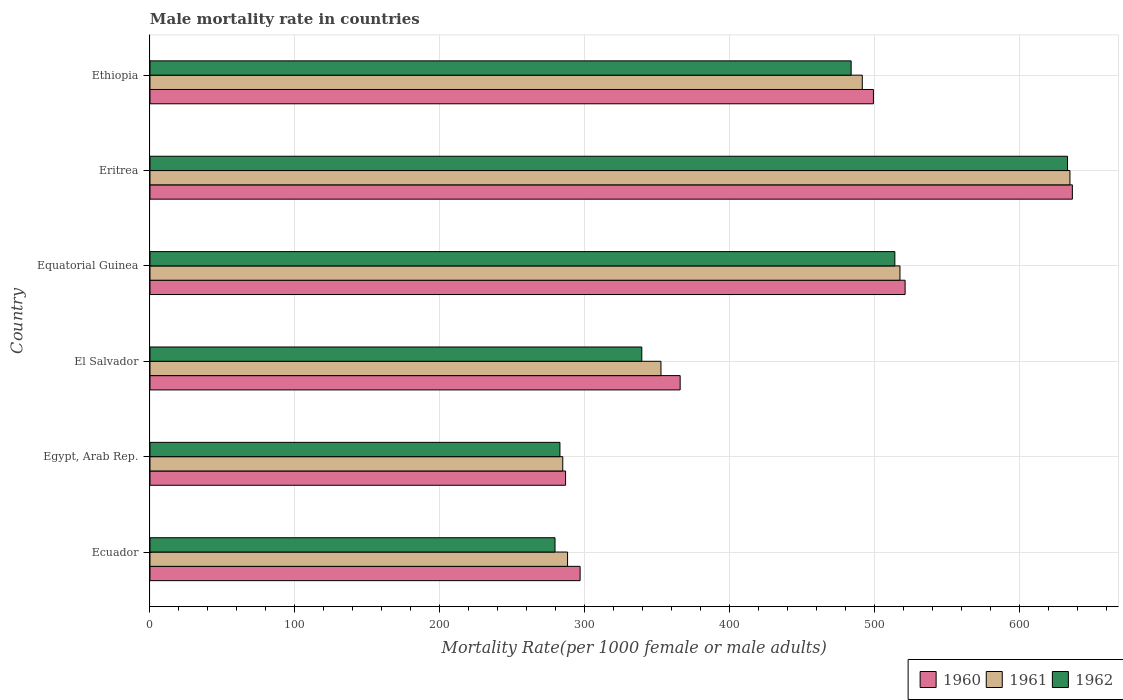How many groups of bars are there?
Give a very brief answer. 6. Are the number of bars per tick equal to the number of legend labels?
Your answer should be very brief. Yes. Are the number of bars on each tick of the Y-axis equal?
Ensure brevity in your answer.  Yes. What is the label of the 6th group of bars from the top?
Provide a short and direct response. Ecuador. In how many cases, is the number of bars for a given country not equal to the number of legend labels?
Ensure brevity in your answer.  0. What is the male mortality rate in 1961 in Equatorial Guinea?
Your answer should be compact. 517.37. Across all countries, what is the maximum male mortality rate in 1961?
Keep it short and to the point. 634.63. Across all countries, what is the minimum male mortality rate in 1962?
Your answer should be very brief. 279.4. In which country was the male mortality rate in 1961 maximum?
Your answer should be compact. Eritrea. In which country was the male mortality rate in 1960 minimum?
Keep it short and to the point. Egypt, Arab Rep. What is the total male mortality rate in 1962 in the graph?
Your answer should be compact. 2531.93. What is the difference between the male mortality rate in 1960 in Eritrea and that in Ethiopia?
Offer a very short reply. 137.24. What is the difference between the male mortality rate in 1960 in El Salvador and the male mortality rate in 1962 in Ecuador?
Provide a succinct answer. 86.32. What is the average male mortality rate in 1961 per country?
Provide a succinct answer. 428.11. What is the difference between the male mortality rate in 1960 and male mortality rate in 1961 in Equatorial Guinea?
Give a very brief answer. 3.54. In how many countries, is the male mortality rate in 1962 greater than 220 ?
Keep it short and to the point. 6. What is the ratio of the male mortality rate in 1962 in El Salvador to that in Ethiopia?
Offer a very short reply. 0.7. What is the difference between the highest and the second highest male mortality rate in 1960?
Your answer should be very brief. 115.39. What is the difference between the highest and the lowest male mortality rate in 1962?
Offer a terse response. 353.55. Is the sum of the male mortality rate in 1961 in Ecuador and El Salvador greater than the maximum male mortality rate in 1962 across all countries?
Give a very brief answer. Yes. What does the 1st bar from the top in Egypt, Arab Rep. represents?
Make the answer very short. 1962. What does the 2nd bar from the bottom in Ethiopia represents?
Offer a very short reply. 1961. Are all the bars in the graph horizontal?
Provide a succinct answer. Yes. Are the values on the major ticks of X-axis written in scientific E-notation?
Offer a very short reply. No. Where does the legend appear in the graph?
Your answer should be compact. Bottom right. How many legend labels are there?
Offer a very short reply. 3. How are the legend labels stacked?
Make the answer very short. Horizontal. What is the title of the graph?
Offer a very short reply. Male mortality rate in countries. What is the label or title of the X-axis?
Provide a succinct answer. Mortality Rate(per 1000 female or male adults). What is the Mortality Rate(per 1000 female or male adults) in 1960 in Ecuador?
Your response must be concise. 296.71. What is the Mortality Rate(per 1000 female or male adults) of 1961 in Ecuador?
Your response must be concise. 288.06. What is the Mortality Rate(per 1000 female or male adults) of 1962 in Ecuador?
Your answer should be very brief. 279.4. What is the Mortality Rate(per 1000 female or male adults) of 1960 in Egypt, Arab Rep.?
Make the answer very short. 286.69. What is the Mortality Rate(per 1000 female or male adults) of 1961 in Egypt, Arab Rep.?
Give a very brief answer. 284.74. What is the Mortality Rate(per 1000 female or male adults) in 1962 in Egypt, Arab Rep.?
Your response must be concise. 282.8. What is the Mortality Rate(per 1000 female or male adults) of 1960 in El Salvador?
Provide a short and direct response. 365.73. What is the Mortality Rate(per 1000 female or male adults) of 1961 in El Salvador?
Provide a short and direct response. 352.5. What is the Mortality Rate(per 1000 female or male adults) in 1962 in El Salvador?
Your answer should be very brief. 339.27. What is the Mortality Rate(per 1000 female or male adults) in 1960 in Equatorial Guinea?
Provide a succinct answer. 520.91. What is the Mortality Rate(per 1000 female or male adults) of 1961 in Equatorial Guinea?
Give a very brief answer. 517.37. What is the Mortality Rate(per 1000 female or male adults) in 1962 in Equatorial Guinea?
Give a very brief answer. 513.83. What is the Mortality Rate(per 1000 female or male adults) in 1960 in Eritrea?
Your answer should be very brief. 636.3. What is the Mortality Rate(per 1000 female or male adults) in 1961 in Eritrea?
Provide a succinct answer. 634.63. What is the Mortality Rate(per 1000 female or male adults) of 1962 in Eritrea?
Give a very brief answer. 632.96. What is the Mortality Rate(per 1000 female or male adults) in 1960 in Ethiopia?
Offer a terse response. 499.05. What is the Mortality Rate(per 1000 female or male adults) in 1961 in Ethiopia?
Provide a succinct answer. 491.37. What is the Mortality Rate(per 1000 female or male adults) in 1962 in Ethiopia?
Keep it short and to the point. 483.68. Across all countries, what is the maximum Mortality Rate(per 1000 female or male adults) in 1960?
Ensure brevity in your answer.  636.3. Across all countries, what is the maximum Mortality Rate(per 1000 female or male adults) in 1961?
Offer a terse response. 634.63. Across all countries, what is the maximum Mortality Rate(per 1000 female or male adults) of 1962?
Provide a succinct answer. 632.96. Across all countries, what is the minimum Mortality Rate(per 1000 female or male adults) of 1960?
Provide a short and direct response. 286.69. Across all countries, what is the minimum Mortality Rate(per 1000 female or male adults) of 1961?
Make the answer very short. 284.74. Across all countries, what is the minimum Mortality Rate(per 1000 female or male adults) of 1962?
Offer a terse response. 279.4. What is the total Mortality Rate(per 1000 female or male adults) of 1960 in the graph?
Provide a short and direct response. 2605.39. What is the total Mortality Rate(per 1000 female or male adults) in 1961 in the graph?
Give a very brief answer. 2568.66. What is the total Mortality Rate(per 1000 female or male adults) of 1962 in the graph?
Offer a terse response. 2531.93. What is the difference between the Mortality Rate(per 1000 female or male adults) of 1960 in Ecuador and that in Egypt, Arab Rep.?
Your response must be concise. 10.02. What is the difference between the Mortality Rate(per 1000 female or male adults) in 1961 in Ecuador and that in Egypt, Arab Rep.?
Ensure brevity in your answer.  3.32. What is the difference between the Mortality Rate(per 1000 female or male adults) of 1962 in Ecuador and that in Egypt, Arab Rep.?
Provide a succinct answer. -3.39. What is the difference between the Mortality Rate(per 1000 female or male adults) of 1960 in Ecuador and that in El Salvador?
Provide a short and direct response. -69.01. What is the difference between the Mortality Rate(per 1000 female or male adults) in 1961 in Ecuador and that in El Salvador?
Offer a very short reply. -64.44. What is the difference between the Mortality Rate(per 1000 female or male adults) in 1962 in Ecuador and that in El Salvador?
Your answer should be very brief. -59.86. What is the difference between the Mortality Rate(per 1000 female or male adults) in 1960 in Ecuador and that in Equatorial Guinea?
Offer a very short reply. -224.2. What is the difference between the Mortality Rate(per 1000 female or male adults) in 1961 in Ecuador and that in Equatorial Guinea?
Ensure brevity in your answer.  -229.31. What is the difference between the Mortality Rate(per 1000 female or male adults) of 1962 in Ecuador and that in Equatorial Guinea?
Provide a succinct answer. -234.42. What is the difference between the Mortality Rate(per 1000 female or male adults) of 1960 in Ecuador and that in Eritrea?
Offer a very short reply. -339.58. What is the difference between the Mortality Rate(per 1000 female or male adults) of 1961 in Ecuador and that in Eritrea?
Keep it short and to the point. -346.57. What is the difference between the Mortality Rate(per 1000 female or male adults) in 1962 in Ecuador and that in Eritrea?
Provide a short and direct response. -353.55. What is the difference between the Mortality Rate(per 1000 female or male adults) of 1960 in Ecuador and that in Ethiopia?
Your answer should be compact. -202.34. What is the difference between the Mortality Rate(per 1000 female or male adults) in 1961 in Ecuador and that in Ethiopia?
Your response must be concise. -203.31. What is the difference between the Mortality Rate(per 1000 female or male adults) of 1962 in Ecuador and that in Ethiopia?
Offer a terse response. -204.28. What is the difference between the Mortality Rate(per 1000 female or male adults) of 1960 in Egypt, Arab Rep. and that in El Salvador?
Make the answer very short. -79.03. What is the difference between the Mortality Rate(per 1000 female or male adults) of 1961 in Egypt, Arab Rep. and that in El Salvador?
Ensure brevity in your answer.  -67.75. What is the difference between the Mortality Rate(per 1000 female or male adults) in 1962 in Egypt, Arab Rep. and that in El Salvador?
Keep it short and to the point. -56.47. What is the difference between the Mortality Rate(per 1000 female or male adults) in 1960 in Egypt, Arab Rep. and that in Equatorial Guinea?
Your response must be concise. -234.22. What is the difference between the Mortality Rate(per 1000 female or male adults) of 1961 in Egypt, Arab Rep. and that in Equatorial Guinea?
Your response must be concise. -232.62. What is the difference between the Mortality Rate(per 1000 female or male adults) in 1962 in Egypt, Arab Rep. and that in Equatorial Guinea?
Your answer should be very brief. -231.03. What is the difference between the Mortality Rate(per 1000 female or male adults) in 1960 in Egypt, Arab Rep. and that in Eritrea?
Your answer should be compact. -349.61. What is the difference between the Mortality Rate(per 1000 female or male adults) in 1961 in Egypt, Arab Rep. and that in Eritrea?
Your answer should be very brief. -349.88. What is the difference between the Mortality Rate(per 1000 female or male adults) in 1962 in Egypt, Arab Rep. and that in Eritrea?
Provide a succinct answer. -350.16. What is the difference between the Mortality Rate(per 1000 female or male adults) of 1960 in Egypt, Arab Rep. and that in Ethiopia?
Your response must be concise. -212.36. What is the difference between the Mortality Rate(per 1000 female or male adults) of 1961 in Egypt, Arab Rep. and that in Ethiopia?
Offer a very short reply. -206.62. What is the difference between the Mortality Rate(per 1000 female or male adults) of 1962 in Egypt, Arab Rep. and that in Ethiopia?
Make the answer very short. -200.89. What is the difference between the Mortality Rate(per 1000 female or male adults) in 1960 in El Salvador and that in Equatorial Guinea?
Keep it short and to the point. -155.19. What is the difference between the Mortality Rate(per 1000 female or male adults) in 1961 in El Salvador and that in Equatorial Guinea?
Your response must be concise. -164.87. What is the difference between the Mortality Rate(per 1000 female or male adults) in 1962 in El Salvador and that in Equatorial Guinea?
Provide a short and direct response. -174.56. What is the difference between the Mortality Rate(per 1000 female or male adults) of 1960 in El Salvador and that in Eritrea?
Your answer should be compact. -270.57. What is the difference between the Mortality Rate(per 1000 female or male adults) in 1961 in El Salvador and that in Eritrea?
Your answer should be very brief. -282.13. What is the difference between the Mortality Rate(per 1000 female or male adults) in 1962 in El Salvador and that in Eritrea?
Keep it short and to the point. -293.69. What is the difference between the Mortality Rate(per 1000 female or male adults) of 1960 in El Salvador and that in Ethiopia?
Your response must be concise. -133.33. What is the difference between the Mortality Rate(per 1000 female or male adults) of 1961 in El Salvador and that in Ethiopia?
Give a very brief answer. -138.87. What is the difference between the Mortality Rate(per 1000 female or male adults) of 1962 in El Salvador and that in Ethiopia?
Provide a short and direct response. -144.42. What is the difference between the Mortality Rate(per 1000 female or male adults) in 1960 in Equatorial Guinea and that in Eritrea?
Ensure brevity in your answer.  -115.39. What is the difference between the Mortality Rate(per 1000 female or male adults) of 1961 in Equatorial Guinea and that in Eritrea?
Ensure brevity in your answer.  -117.26. What is the difference between the Mortality Rate(per 1000 female or male adults) in 1962 in Equatorial Guinea and that in Eritrea?
Make the answer very short. -119.13. What is the difference between the Mortality Rate(per 1000 female or male adults) of 1960 in Equatorial Guinea and that in Ethiopia?
Your answer should be very brief. 21.86. What is the difference between the Mortality Rate(per 1000 female or male adults) of 1961 in Equatorial Guinea and that in Ethiopia?
Offer a very short reply. 26. What is the difference between the Mortality Rate(per 1000 female or male adults) in 1962 in Equatorial Guinea and that in Ethiopia?
Provide a short and direct response. 30.15. What is the difference between the Mortality Rate(per 1000 female or male adults) of 1960 in Eritrea and that in Ethiopia?
Ensure brevity in your answer.  137.24. What is the difference between the Mortality Rate(per 1000 female or male adults) in 1961 in Eritrea and that in Ethiopia?
Your answer should be very brief. 143.26. What is the difference between the Mortality Rate(per 1000 female or male adults) in 1962 in Eritrea and that in Ethiopia?
Ensure brevity in your answer.  149.28. What is the difference between the Mortality Rate(per 1000 female or male adults) in 1960 in Ecuador and the Mortality Rate(per 1000 female or male adults) in 1961 in Egypt, Arab Rep.?
Offer a terse response. 11.97. What is the difference between the Mortality Rate(per 1000 female or male adults) of 1960 in Ecuador and the Mortality Rate(per 1000 female or male adults) of 1962 in Egypt, Arab Rep.?
Your answer should be compact. 13.92. What is the difference between the Mortality Rate(per 1000 female or male adults) of 1961 in Ecuador and the Mortality Rate(per 1000 female or male adults) of 1962 in Egypt, Arab Rep.?
Give a very brief answer. 5.26. What is the difference between the Mortality Rate(per 1000 female or male adults) in 1960 in Ecuador and the Mortality Rate(per 1000 female or male adults) in 1961 in El Salvador?
Make the answer very short. -55.78. What is the difference between the Mortality Rate(per 1000 female or male adults) of 1960 in Ecuador and the Mortality Rate(per 1000 female or male adults) of 1962 in El Salvador?
Keep it short and to the point. -42.55. What is the difference between the Mortality Rate(per 1000 female or male adults) of 1961 in Ecuador and the Mortality Rate(per 1000 female or male adults) of 1962 in El Salvador?
Your answer should be very brief. -51.21. What is the difference between the Mortality Rate(per 1000 female or male adults) of 1960 in Ecuador and the Mortality Rate(per 1000 female or male adults) of 1961 in Equatorial Guinea?
Make the answer very short. -220.66. What is the difference between the Mortality Rate(per 1000 female or male adults) of 1960 in Ecuador and the Mortality Rate(per 1000 female or male adults) of 1962 in Equatorial Guinea?
Ensure brevity in your answer.  -217.11. What is the difference between the Mortality Rate(per 1000 female or male adults) in 1961 in Ecuador and the Mortality Rate(per 1000 female or male adults) in 1962 in Equatorial Guinea?
Offer a terse response. -225.77. What is the difference between the Mortality Rate(per 1000 female or male adults) of 1960 in Ecuador and the Mortality Rate(per 1000 female or male adults) of 1961 in Eritrea?
Your answer should be compact. -337.91. What is the difference between the Mortality Rate(per 1000 female or male adults) of 1960 in Ecuador and the Mortality Rate(per 1000 female or male adults) of 1962 in Eritrea?
Your response must be concise. -336.24. What is the difference between the Mortality Rate(per 1000 female or male adults) in 1961 in Ecuador and the Mortality Rate(per 1000 female or male adults) in 1962 in Eritrea?
Ensure brevity in your answer.  -344.9. What is the difference between the Mortality Rate(per 1000 female or male adults) of 1960 in Ecuador and the Mortality Rate(per 1000 female or male adults) of 1961 in Ethiopia?
Your answer should be compact. -194.65. What is the difference between the Mortality Rate(per 1000 female or male adults) in 1960 in Ecuador and the Mortality Rate(per 1000 female or male adults) in 1962 in Ethiopia?
Provide a succinct answer. -186.97. What is the difference between the Mortality Rate(per 1000 female or male adults) in 1961 in Ecuador and the Mortality Rate(per 1000 female or male adults) in 1962 in Ethiopia?
Your response must be concise. -195.62. What is the difference between the Mortality Rate(per 1000 female or male adults) of 1960 in Egypt, Arab Rep. and the Mortality Rate(per 1000 female or male adults) of 1961 in El Salvador?
Provide a succinct answer. -65.8. What is the difference between the Mortality Rate(per 1000 female or male adults) in 1960 in Egypt, Arab Rep. and the Mortality Rate(per 1000 female or male adults) in 1962 in El Salvador?
Provide a succinct answer. -52.57. What is the difference between the Mortality Rate(per 1000 female or male adults) of 1961 in Egypt, Arab Rep. and the Mortality Rate(per 1000 female or male adults) of 1962 in El Salvador?
Offer a terse response. -54.52. What is the difference between the Mortality Rate(per 1000 female or male adults) of 1960 in Egypt, Arab Rep. and the Mortality Rate(per 1000 female or male adults) of 1961 in Equatorial Guinea?
Make the answer very short. -230.68. What is the difference between the Mortality Rate(per 1000 female or male adults) in 1960 in Egypt, Arab Rep. and the Mortality Rate(per 1000 female or male adults) in 1962 in Equatorial Guinea?
Your response must be concise. -227.14. What is the difference between the Mortality Rate(per 1000 female or male adults) in 1961 in Egypt, Arab Rep. and the Mortality Rate(per 1000 female or male adults) in 1962 in Equatorial Guinea?
Your answer should be compact. -229.08. What is the difference between the Mortality Rate(per 1000 female or male adults) in 1960 in Egypt, Arab Rep. and the Mortality Rate(per 1000 female or male adults) in 1961 in Eritrea?
Your answer should be very brief. -347.94. What is the difference between the Mortality Rate(per 1000 female or male adults) in 1960 in Egypt, Arab Rep. and the Mortality Rate(per 1000 female or male adults) in 1962 in Eritrea?
Keep it short and to the point. -346.26. What is the difference between the Mortality Rate(per 1000 female or male adults) in 1961 in Egypt, Arab Rep. and the Mortality Rate(per 1000 female or male adults) in 1962 in Eritrea?
Your response must be concise. -348.21. What is the difference between the Mortality Rate(per 1000 female or male adults) in 1960 in Egypt, Arab Rep. and the Mortality Rate(per 1000 female or male adults) in 1961 in Ethiopia?
Your answer should be very brief. -204.68. What is the difference between the Mortality Rate(per 1000 female or male adults) of 1960 in Egypt, Arab Rep. and the Mortality Rate(per 1000 female or male adults) of 1962 in Ethiopia?
Give a very brief answer. -196.99. What is the difference between the Mortality Rate(per 1000 female or male adults) of 1961 in Egypt, Arab Rep. and the Mortality Rate(per 1000 female or male adults) of 1962 in Ethiopia?
Offer a very short reply. -198.94. What is the difference between the Mortality Rate(per 1000 female or male adults) in 1960 in El Salvador and the Mortality Rate(per 1000 female or male adults) in 1961 in Equatorial Guinea?
Your response must be concise. -151.64. What is the difference between the Mortality Rate(per 1000 female or male adults) of 1960 in El Salvador and the Mortality Rate(per 1000 female or male adults) of 1962 in Equatorial Guinea?
Ensure brevity in your answer.  -148.1. What is the difference between the Mortality Rate(per 1000 female or male adults) of 1961 in El Salvador and the Mortality Rate(per 1000 female or male adults) of 1962 in Equatorial Guinea?
Make the answer very short. -161.33. What is the difference between the Mortality Rate(per 1000 female or male adults) in 1960 in El Salvador and the Mortality Rate(per 1000 female or male adults) in 1961 in Eritrea?
Give a very brief answer. -268.9. What is the difference between the Mortality Rate(per 1000 female or male adults) in 1960 in El Salvador and the Mortality Rate(per 1000 female or male adults) in 1962 in Eritrea?
Make the answer very short. -267.23. What is the difference between the Mortality Rate(per 1000 female or male adults) in 1961 in El Salvador and the Mortality Rate(per 1000 female or male adults) in 1962 in Eritrea?
Provide a succinct answer. -280.46. What is the difference between the Mortality Rate(per 1000 female or male adults) in 1960 in El Salvador and the Mortality Rate(per 1000 female or male adults) in 1961 in Ethiopia?
Offer a terse response. -125.64. What is the difference between the Mortality Rate(per 1000 female or male adults) of 1960 in El Salvador and the Mortality Rate(per 1000 female or male adults) of 1962 in Ethiopia?
Your response must be concise. -117.96. What is the difference between the Mortality Rate(per 1000 female or male adults) of 1961 in El Salvador and the Mortality Rate(per 1000 female or male adults) of 1962 in Ethiopia?
Your answer should be very brief. -131.19. What is the difference between the Mortality Rate(per 1000 female or male adults) of 1960 in Equatorial Guinea and the Mortality Rate(per 1000 female or male adults) of 1961 in Eritrea?
Keep it short and to the point. -113.72. What is the difference between the Mortality Rate(per 1000 female or male adults) in 1960 in Equatorial Guinea and the Mortality Rate(per 1000 female or male adults) in 1962 in Eritrea?
Offer a terse response. -112.05. What is the difference between the Mortality Rate(per 1000 female or male adults) in 1961 in Equatorial Guinea and the Mortality Rate(per 1000 female or male adults) in 1962 in Eritrea?
Your answer should be compact. -115.59. What is the difference between the Mortality Rate(per 1000 female or male adults) in 1960 in Equatorial Guinea and the Mortality Rate(per 1000 female or male adults) in 1961 in Ethiopia?
Offer a terse response. 29.54. What is the difference between the Mortality Rate(per 1000 female or male adults) in 1960 in Equatorial Guinea and the Mortality Rate(per 1000 female or male adults) in 1962 in Ethiopia?
Ensure brevity in your answer.  37.23. What is the difference between the Mortality Rate(per 1000 female or male adults) in 1961 in Equatorial Guinea and the Mortality Rate(per 1000 female or male adults) in 1962 in Ethiopia?
Provide a short and direct response. 33.69. What is the difference between the Mortality Rate(per 1000 female or male adults) of 1960 in Eritrea and the Mortality Rate(per 1000 female or male adults) of 1961 in Ethiopia?
Ensure brevity in your answer.  144.93. What is the difference between the Mortality Rate(per 1000 female or male adults) of 1960 in Eritrea and the Mortality Rate(per 1000 female or male adults) of 1962 in Ethiopia?
Provide a succinct answer. 152.62. What is the difference between the Mortality Rate(per 1000 female or male adults) in 1961 in Eritrea and the Mortality Rate(per 1000 female or male adults) in 1962 in Ethiopia?
Your response must be concise. 150.94. What is the average Mortality Rate(per 1000 female or male adults) of 1960 per country?
Offer a terse response. 434.23. What is the average Mortality Rate(per 1000 female or male adults) of 1961 per country?
Provide a succinct answer. 428.11. What is the average Mortality Rate(per 1000 female or male adults) of 1962 per country?
Keep it short and to the point. 421.99. What is the difference between the Mortality Rate(per 1000 female or male adults) in 1960 and Mortality Rate(per 1000 female or male adults) in 1961 in Ecuador?
Your response must be concise. 8.65. What is the difference between the Mortality Rate(per 1000 female or male adults) of 1960 and Mortality Rate(per 1000 female or male adults) of 1962 in Ecuador?
Your response must be concise. 17.31. What is the difference between the Mortality Rate(per 1000 female or male adults) in 1961 and Mortality Rate(per 1000 female or male adults) in 1962 in Ecuador?
Offer a very short reply. 8.65. What is the difference between the Mortality Rate(per 1000 female or male adults) in 1960 and Mortality Rate(per 1000 female or male adults) in 1961 in Egypt, Arab Rep.?
Offer a terse response. 1.95. What is the difference between the Mortality Rate(per 1000 female or male adults) of 1960 and Mortality Rate(per 1000 female or male adults) of 1962 in Egypt, Arab Rep.?
Your answer should be compact. 3.9. What is the difference between the Mortality Rate(per 1000 female or male adults) in 1961 and Mortality Rate(per 1000 female or male adults) in 1962 in Egypt, Arab Rep.?
Your response must be concise. 1.95. What is the difference between the Mortality Rate(per 1000 female or male adults) in 1960 and Mortality Rate(per 1000 female or male adults) in 1961 in El Salvador?
Provide a short and direct response. 13.23. What is the difference between the Mortality Rate(per 1000 female or male adults) of 1960 and Mortality Rate(per 1000 female or male adults) of 1962 in El Salvador?
Provide a succinct answer. 26.46. What is the difference between the Mortality Rate(per 1000 female or male adults) of 1961 and Mortality Rate(per 1000 female or male adults) of 1962 in El Salvador?
Give a very brief answer. 13.23. What is the difference between the Mortality Rate(per 1000 female or male adults) in 1960 and Mortality Rate(per 1000 female or male adults) in 1961 in Equatorial Guinea?
Provide a succinct answer. 3.54. What is the difference between the Mortality Rate(per 1000 female or male adults) of 1960 and Mortality Rate(per 1000 female or male adults) of 1962 in Equatorial Guinea?
Provide a succinct answer. 7.08. What is the difference between the Mortality Rate(per 1000 female or male adults) in 1961 and Mortality Rate(per 1000 female or male adults) in 1962 in Equatorial Guinea?
Your answer should be very brief. 3.54. What is the difference between the Mortality Rate(per 1000 female or male adults) in 1960 and Mortality Rate(per 1000 female or male adults) in 1961 in Eritrea?
Keep it short and to the point. 1.67. What is the difference between the Mortality Rate(per 1000 female or male adults) of 1960 and Mortality Rate(per 1000 female or male adults) of 1962 in Eritrea?
Your response must be concise. 3.34. What is the difference between the Mortality Rate(per 1000 female or male adults) in 1961 and Mortality Rate(per 1000 female or male adults) in 1962 in Eritrea?
Make the answer very short. 1.67. What is the difference between the Mortality Rate(per 1000 female or male adults) in 1960 and Mortality Rate(per 1000 female or male adults) in 1961 in Ethiopia?
Keep it short and to the point. 7.69. What is the difference between the Mortality Rate(per 1000 female or male adults) in 1960 and Mortality Rate(per 1000 female or male adults) in 1962 in Ethiopia?
Offer a very short reply. 15.37. What is the difference between the Mortality Rate(per 1000 female or male adults) in 1961 and Mortality Rate(per 1000 female or male adults) in 1962 in Ethiopia?
Your response must be concise. 7.69. What is the ratio of the Mortality Rate(per 1000 female or male adults) of 1960 in Ecuador to that in Egypt, Arab Rep.?
Your answer should be compact. 1.03. What is the ratio of the Mortality Rate(per 1000 female or male adults) of 1961 in Ecuador to that in Egypt, Arab Rep.?
Your response must be concise. 1.01. What is the ratio of the Mortality Rate(per 1000 female or male adults) of 1962 in Ecuador to that in Egypt, Arab Rep.?
Your response must be concise. 0.99. What is the ratio of the Mortality Rate(per 1000 female or male adults) of 1960 in Ecuador to that in El Salvador?
Your response must be concise. 0.81. What is the ratio of the Mortality Rate(per 1000 female or male adults) in 1961 in Ecuador to that in El Salvador?
Your answer should be compact. 0.82. What is the ratio of the Mortality Rate(per 1000 female or male adults) of 1962 in Ecuador to that in El Salvador?
Make the answer very short. 0.82. What is the ratio of the Mortality Rate(per 1000 female or male adults) in 1960 in Ecuador to that in Equatorial Guinea?
Make the answer very short. 0.57. What is the ratio of the Mortality Rate(per 1000 female or male adults) of 1961 in Ecuador to that in Equatorial Guinea?
Make the answer very short. 0.56. What is the ratio of the Mortality Rate(per 1000 female or male adults) in 1962 in Ecuador to that in Equatorial Guinea?
Offer a terse response. 0.54. What is the ratio of the Mortality Rate(per 1000 female or male adults) of 1960 in Ecuador to that in Eritrea?
Give a very brief answer. 0.47. What is the ratio of the Mortality Rate(per 1000 female or male adults) of 1961 in Ecuador to that in Eritrea?
Your answer should be very brief. 0.45. What is the ratio of the Mortality Rate(per 1000 female or male adults) of 1962 in Ecuador to that in Eritrea?
Ensure brevity in your answer.  0.44. What is the ratio of the Mortality Rate(per 1000 female or male adults) of 1960 in Ecuador to that in Ethiopia?
Your response must be concise. 0.59. What is the ratio of the Mortality Rate(per 1000 female or male adults) in 1961 in Ecuador to that in Ethiopia?
Give a very brief answer. 0.59. What is the ratio of the Mortality Rate(per 1000 female or male adults) in 1962 in Ecuador to that in Ethiopia?
Your answer should be compact. 0.58. What is the ratio of the Mortality Rate(per 1000 female or male adults) in 1960 in Egypt, Arab Rep. to that in El Salvador?
Provide a short and direct response. 0.78. What is the ratio of the Mortality Rate(per 1000 female or male adults) of 1961 in Egypt, Arab Rep. to that in El Salvador?
Ensure brevity in your answer.  0.81. What is the ratio of the Mortality Rate(per 1000 female or male adults) of 1962 in Egypt, Arab Rep. to that in El Salvador?
Make the answer very short. 0.83. What is the ratio of the Mortality Rate(per 1000 female or male adults) in 1960 in Egypt, Arab Rep. to that in Equatorial Guinea?
Offer a very short reply. 0.55. What is the ratio of the Mortality Rate(per 1000 female or male adults) in 1961 in Egypt, Arab Rep. to that in Equatorial Guinea?
Offer a terse response. 0.55. What is the ratio of the Mortality Rate(per 1000 female or male adults) in 1962 in Egypt, Arab Rep. to that in Equatorial Guinea?
Keep it short and to the point. 0.55. What is the ratio of the Mortality Rate(per 1000 female or male adults) in 1960 in Egypt, Arab Rep. to that in Eritrea?
Provide a short and direct response. 0.45. What is the ratio of the Mortality Rate(per 1000 female or male adults) in 1961 in Egypt, Arab Rep. to that in Eritrea?
Give a very brief answer. 0.45. What is the ratio of the Mortality Rate(per 1000 female or male adults) of 1962 in Egypt, Arab Rep. to that in Eritrea?
Give a very brief answer. 0.45. What is the ratio of the Mortality Rate(per 1000 female or male adults) in 1960 in Egypt, Arab Rep. to that in Ethiopia?
Provide a succinct answer. 0.57. What is the ratio of the Mortality Rate(per 1000 female or male adults) of 1961 in Egypt, Arab Rep. to that in Ethiopia?
Provide a short and direct response. 0.58. What is the ratio of the Mortality Rate(per 1000 female or male adults) in 1962 in Egypt, Arab Rep. to that in Ethiopia?
Offer a terse response. 0.58. What is the ratio of the Mortality Rate(per 1000 female or male adults) in 1960 in El Salvador to that in Equatorial Guinea?
Provide a short and direct response. 0.7. What is the ratio of the Mortality Rate(per 1000 female or male adults) of 1961 in El Salvador to that in Equatorial Guinea?
Provide a short and direct response. 0.68. What is the ratio of the Mortality Rate(per 1000 female or male adults) in 1962 in El Salvador to that in Equatorial Guinea?
Provide a short and direct response. 0.66. What is the ratio of the Mortality Rate(per 1000 female or male adults) in 1960 in El Salvador to that in Eritrea?
Your answer should be very brief. 0.57. What is the ratio of the Mortality Rate(per 1000 female or male adults) in 1961 in El Salvador to that in Eritrea?
Provide a succinct answer. 0.56. What is the ratio of the Mortality Rate(per 1000 female or male adults) in 1962 in El Salvador to that in Eritrea?
Provide a short and direct response. 0.54. What is the ratio of the Mortality Rate(per 1000 female or male adults) of 1960 in El Salvador to that in Ethiopia?
Provide a succinct answer. 0.73. What is the ratio of the Mortality Rate(per 1000 female or male adults) in 1961 in El Salvador to that in Ethiopia?
Provide a succinct answer. 0.72. What is the ratio of the Mortality Rate(per 1000 female or male adults) in 1962 in El Salvador to that in Ethiopia?
Your answer should be compact. 0.7. What is the ratio of the Mortality Rate(per 1000 female or male adults) in 1960 in Equatorial Guinea to that in Eritrea?
Ensure brevity in your answer.  0.82. What is the ratio of the Mortality Rate(per 1000 female or male adults) in 1961 in Equatorial Guinea to that in Eritrea?
Offer a very short reply. 0.82. What is the ratio of the Mortality Rate(per 1000 female or male adults) in 1962 in Equatorial Guinea to that in Eritrea?
Ensure brevity in your answer.  0.81. What is the ratio of the Mortality Rate(per 1000 female or male adults) of 1960 in Equatorial Guinea to that in Ethiopia?
Offer a terse response. 1.04. What is the ratio of the Mortality Rate(per 1000 female or male adults) of 1961 in Equatorial Guinea to that in Ethiopia?
Give a very brief answer. 1.05. What is the ratio of the Mortality Rate(per 1000 female or male adults) in 1962 in Equatorial Guinea to that in Ethiopia?
Provide a succinct answer. 1.06. What is the ratio of the Mortality Rate(per 1000 female or male adults) in 1960 in Eritrea to that in Ethiopia?
Your response must be concise. 1.27. What is the ratio of the Mortality Rate(per 1000 female or male adults) of 1961 in Eritrea to that in Ethiopia?
Provide a short and direct response. 1.29. What is the ratio of the Mortality Rate(per 1000 female or male adults) of 1962 in Eritrea to that in Ethiopia?
Your answer should be very brief. 1.31. What is the difference between the highest and the second highest Mortality Rate(per 1000 female or male adults) in 1960?
Your answer should be compact. 115.39. What is the difference between the highest and the second highest Mortality Rate(per 1000 female or male adults) of 1961?
Your answer should be compact. 117.26. What is the difference between the highest and the second highest Mortality Rate(per 1000 female or male adults) of 1962?
Offer a very short reply. 119.13. What is the difference between the highest and the lowest Mortality Rate(per 1000 female or male adults) of 1960?
Provide a short and direct response. 349.61. What is the difference between the highest and the lowest Mortality Rate(per 1000 female or male adults) in 1961?
Your answer should be very brief. 349.88. What is the difference between the highest and the lowest Mortality Rate(per 1000 female or male adults) in 1962?
Your answer should be very brief. 353.55. 